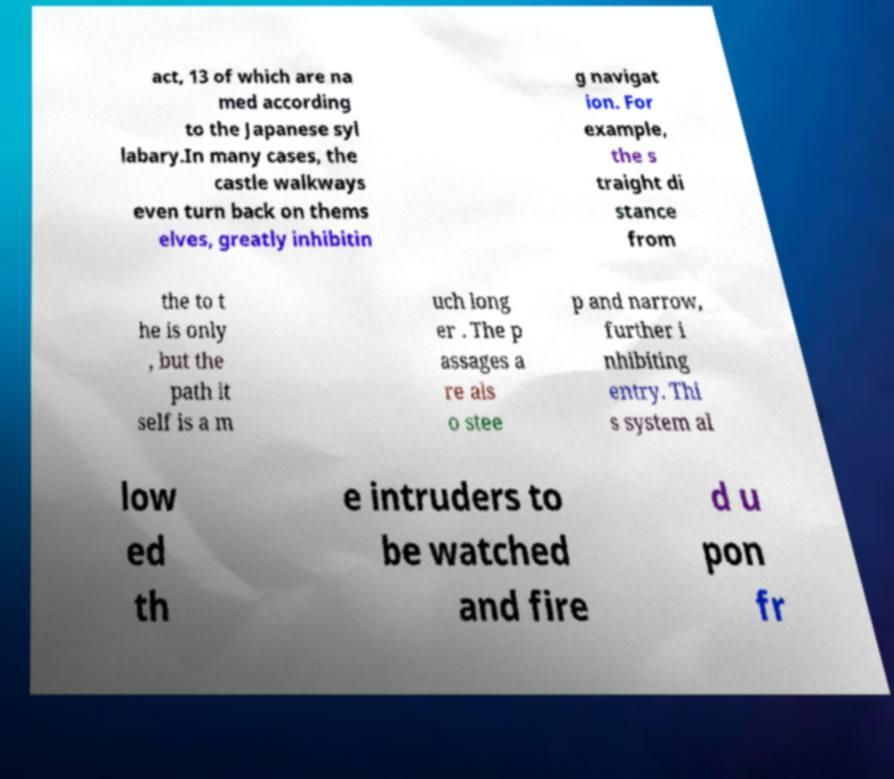Could you assist in decoding the text presented in this image and type it out clearly? act, 13 of which are na med according to the Japanese syl labary.In many cases, the castle walkways even turn back on thems elves, greatly inhibitin g navigat ion. For example, the s traight di stance from the to t he is only , but the path it self is a m uch long er . The p assages a re als o stee p and narrow, further i nhibiting entry. Thi s system al low ed th e intruders to be watched and fire d u pon fr 